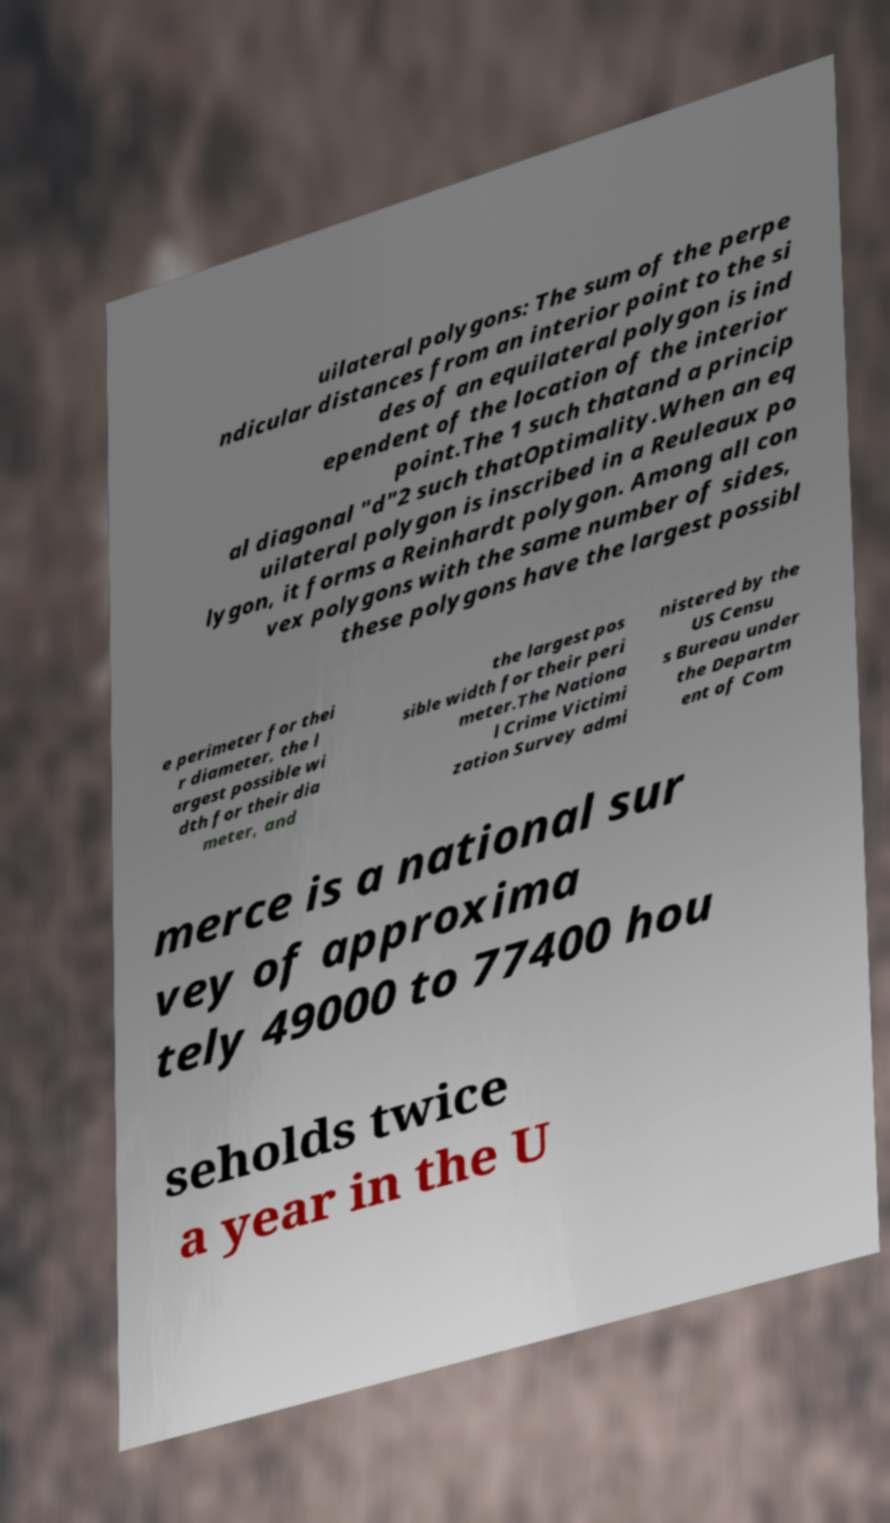For documentation purposes, I need the text within this image transcribed. Could you provide that? uilateral polygons: The sum of the perpe ndicular distances from an interior point to the si des of an equilateral polygon is ind ependent of the location of the interior point.The 1 such thatand a princip al diagonal "d"2 such thatOptimality.When an eq uilateral polygon is inscribed in a Reuleaux po lygon, it forms a Reinhardt polygon. Among all con vex polygons with the same number of sides, these polygons have the largest possibl e perimeter for thei r diameter, the l argest possible wi dth for their dia meter, and the largest pos sible width for their peri meter.The Nationa l Crime Victimi zation Survey admi nistered by the US Censu s Bureau under the Departm ent of Com merce is a national sur vey of approxima tely 49000 to 77400 hou seholds twice a year in the U 